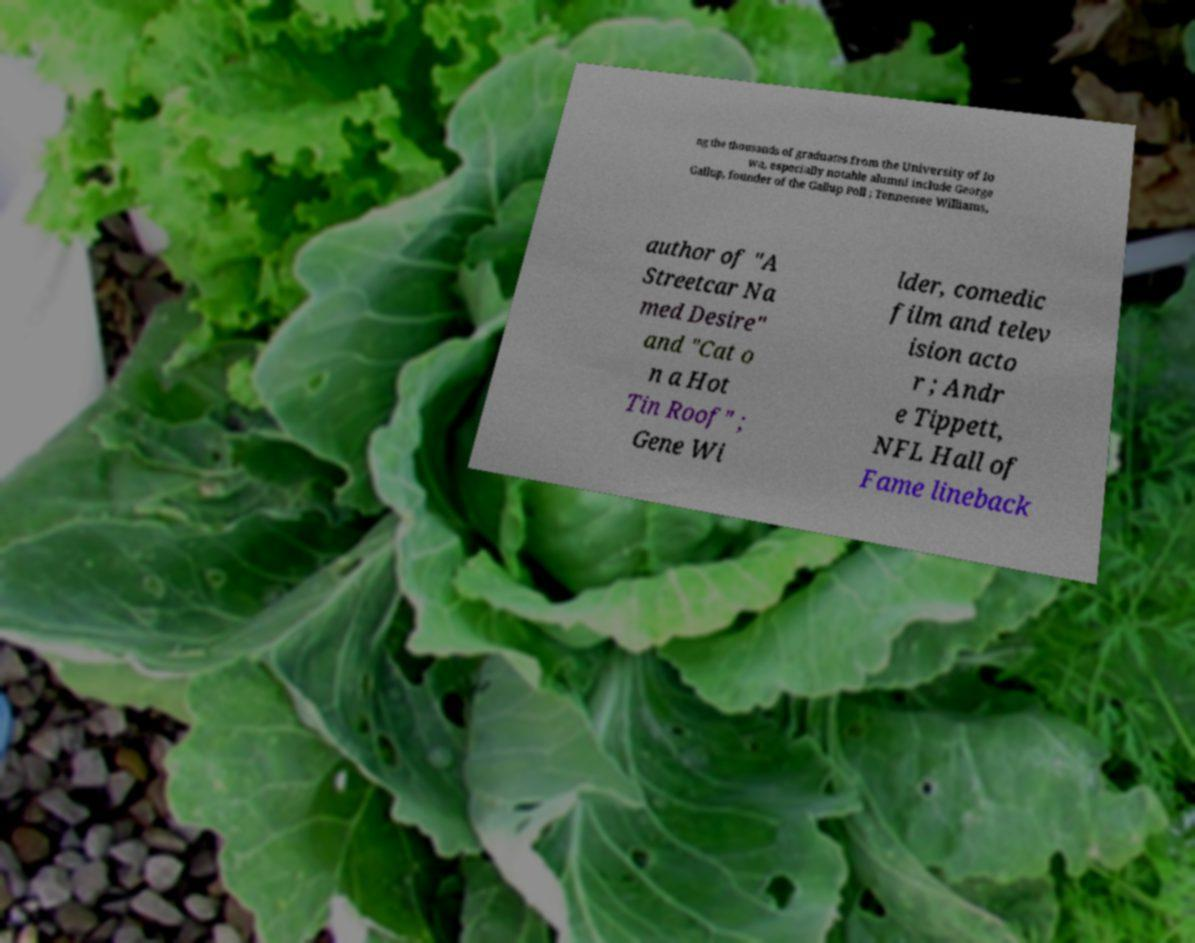Could you extract and type out the text from this image? ng the thousands of graduates from the University of Io wa, especially notable alumni include George Gallup, founder of the Gallup Poll ; Tennessee Williams, author of "A Streetcar Na med Desire" and "Cat o n a Hot Tin Roof" ; Gene Wi lder, comedic film and telev ision acto r ; Andr e Tippett, NFL Hall of Fame lineback 